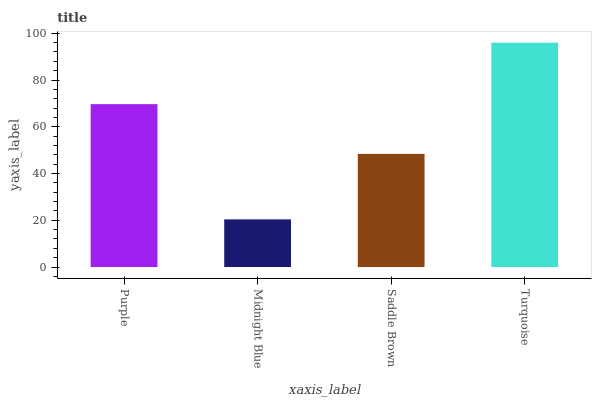Is Saddle Brown the minimum?
Answer yes or no. No. Is Saddle Brown the maximum?
Answer yes or no. No. Is Saddle Brown greater than Midnight Blue?
Answer yes or no. Yes. Is Midnight Blue less than Saddle Brown?
Answer yes or no. Yes. Is Midnight Blue greater than Saddle Brown?
Answer yes or no. No. Is Saddle Brown less than Midnight Blue?
Answer yes or no. No. Is Purple the high median?
Answer yes or no. Yes. Is Saddle Brown the low median?
Answer yes or no. Yes. Is Turquoise the high median?
Answer yes or no. No. Is Midnight Blue the low median?
Answer yes or no. No. 